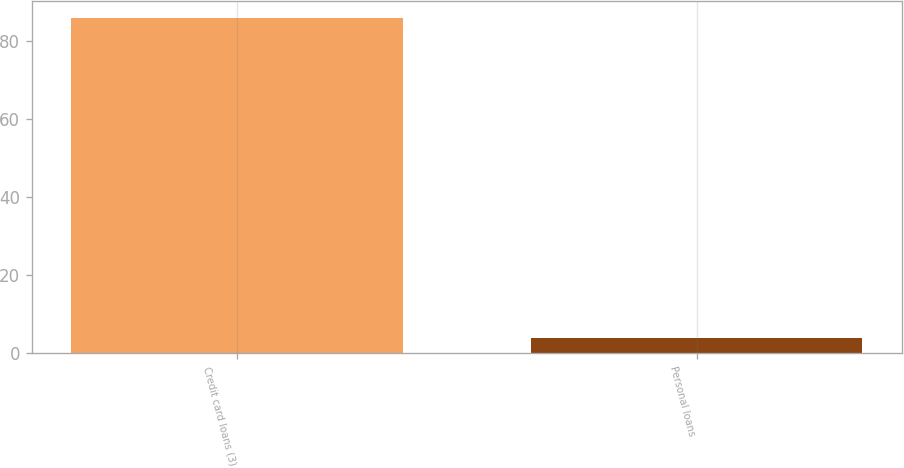Convert chart. <chart><loc_0><loc_0><loc_500><loc_500><bar_chart><fcel>Credit card loans (3)<fcel>Personal loans<nl><fcel>86<fcel>4<nl></chart> 